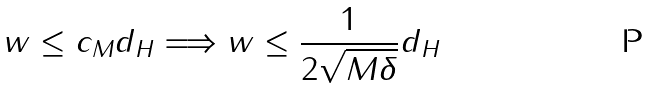Convert formula to latex. <formula><loc_0><loc_0><loc_500><loc_500>\| w \| \leq c _ { M } d _ { H } \Longrightarrow \| w \| \leq \frac { 1 } { 2 \sqrt { M \delta } } d _ { H }</formula> 